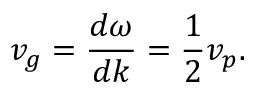Convert formula to latex. <formula><loc_0><loc_0><loc_500><loc_500>v _ { g } = { \frac { d \omega } { d k } } = { \frac { 1 } { 2 } } v _ { p } .</formula> 